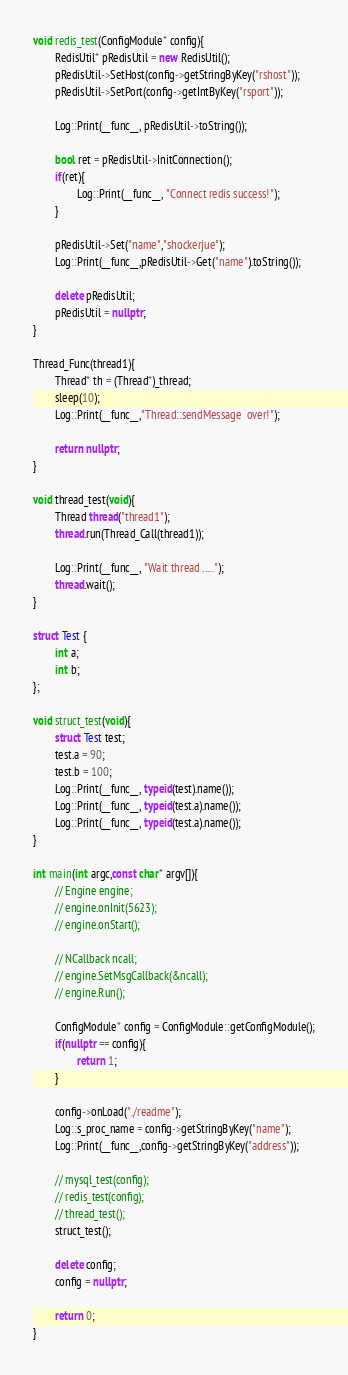Convert code to text. <code><loc_0><loc_0><loc_500><loc_500><_C++_>void redis_test(ConfigModule* config){
        RedisUtil* pRedisUtil = new RedisUtil();
        pRedisUtil->SetHost(config->getStringByKey("rshost"));
        pRedisUtil->SetPort(config->getIntByKey("rsport"));

        Log::Print(__func__, pRedisUtil->toString());

        bool ret = pRedisUtil->InitConnection();
        if(ret){
                Log::Print(__func__, "Connect redis success!");
        }

        pRedisUtil->Set("name","shockerjue");
        Log::Print(__func__,pRedisUtil->Get("name").toString());

        delete pRedisUtil;
        pRedisUtil = nullptr;
}

Thread_Func(thread1){
        Thread* th = (Thread*)_thread;
        sleep(10);
        Log::Print(__func__,"Thread::sendMessage  over!");

        return nullptr;
}

void thread_test(void){
        Thread thread("thread1");
        thread.run(Thread_Call(thread1));

        Log::Print(__func__, "Wait thread .....");
        thread.wait();  
}

struct Test {
        int a;
        int b;
};

void struct_test(void){
        struct Test test;
        test.a = 90;
        test.b = 100;
        Log::Print(__func__, typeid(test).name());
        Log::Print(__func__, typeid(test.a).name());
        Log::Print(__func__, typeid(test.a).name());
}

int main(int argc,const char* argv[]){
        // Engine engine;
        // engine.onInit(5623);
        // engine.onStart();

        // NCallback ncall;
        // engine.SetMsgCallback(&ncall);
        // engine.Run();

        ConfigModule* config = ConfigModule::getConfigModule();
        if(nullptr == config){
                return 1;
        }

        config->onLoad("./readme");
        Log::s_proc_name = config->getStringByKey("name");
        Log::Print(__func__,config->getStringByKey("address"));
        
        // mysql_test(config);
        // redis_test(config);
        // thread_test();
        struct_test();

        delete config;
        config = nullptr;
        
        return 0;
}</code> 